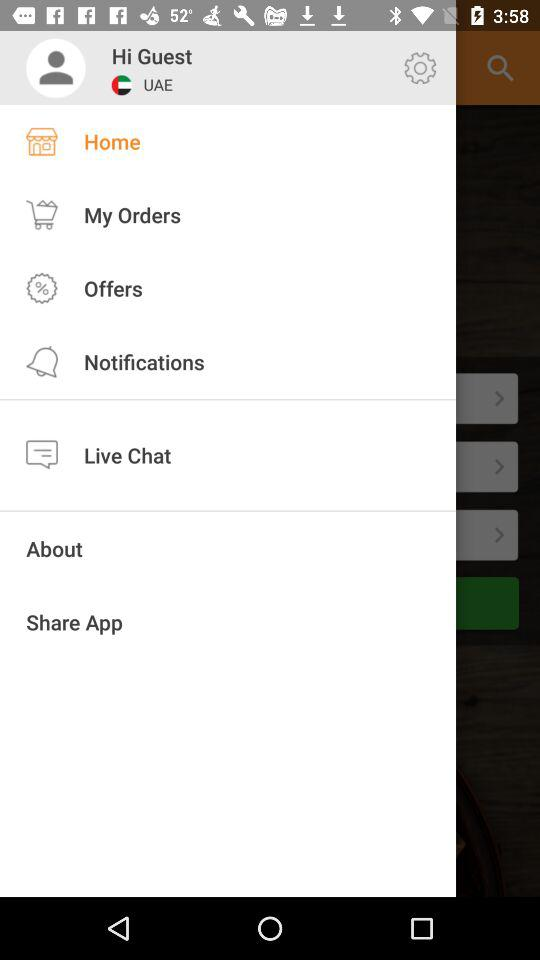What is the location of the guest? The guest's location is the UAE. 